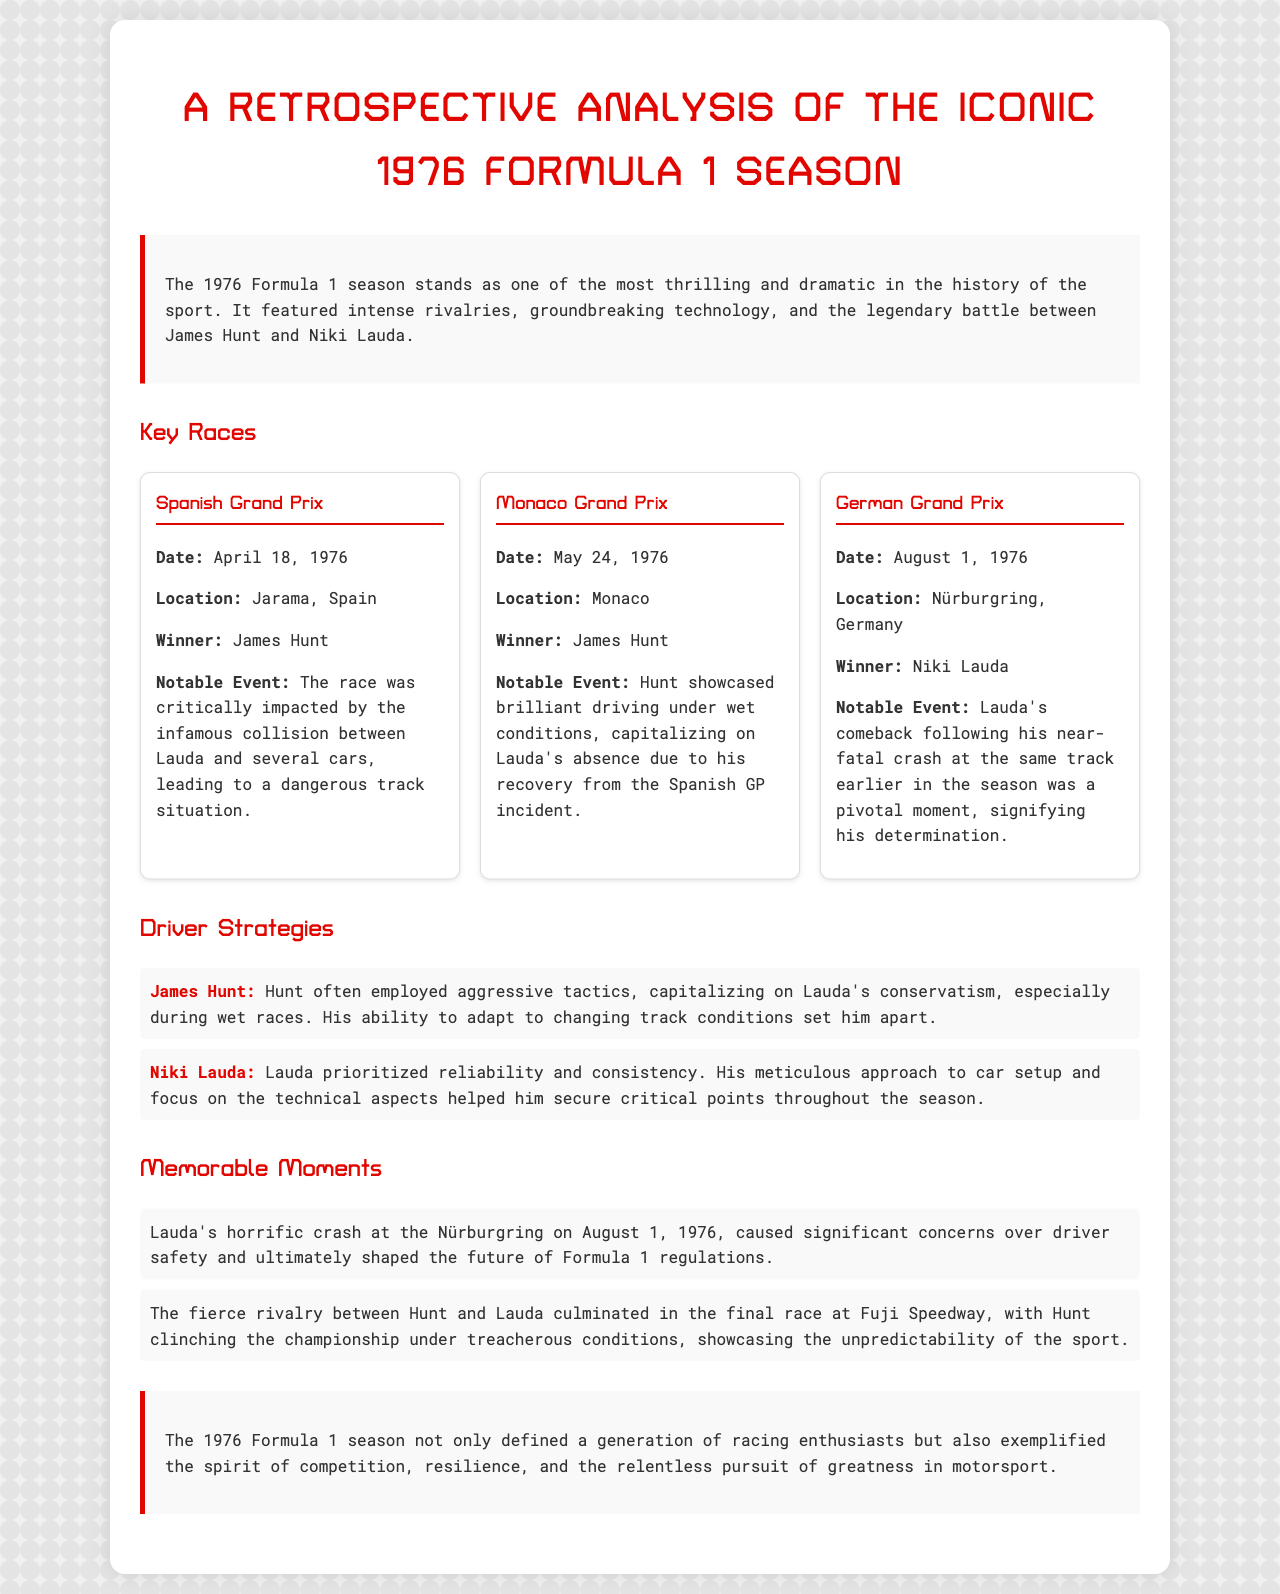What was the date of the Spanish Grand Prix? The document states that the Spanish Grand Prix took place on April 18, 1976.
Answer: April 18, 1976 Who won the Monaco Grand Prix? According to the report, James Hunt secured victory at the Monaco Grand Prix.
Answer: James Hunt What was a notable event at the German Grand Prix? The document highlights Lauda's comeback following his near-fatal crash as a significant event at the German Grand Prix.
Answer: Lauda's comeback after his crash Which driver was known for aggressive tactics? The report specifically notes that James Hunt employed aggressive tactics during the season.
Answer: James Hunt What notable event impacted Lauda during the season? The document refers to Lauda's horrific crash at the Nürburgring, impacting driver safety discussions in F1.
Answer: Lauda's horrific crash at Nürburgring How did Hunt's strategy differ from Lauda's? The document mentions that Hunt capitalized on Lauda's conservatism, while Lauda prioritized reliability and consistency.
Answer: Hunt was aggressive, Lauda focused on reliability What was the final race location in the 1976 season? The report states that the final race took place at Fuji Speedway.
Answer: Fuji Speedway What significant theme does the conclusion emphasize? The conclusion of the document emphasizes the spirit of competition and resilience in motorsport.
Answer: Spirit of competition and resilience 